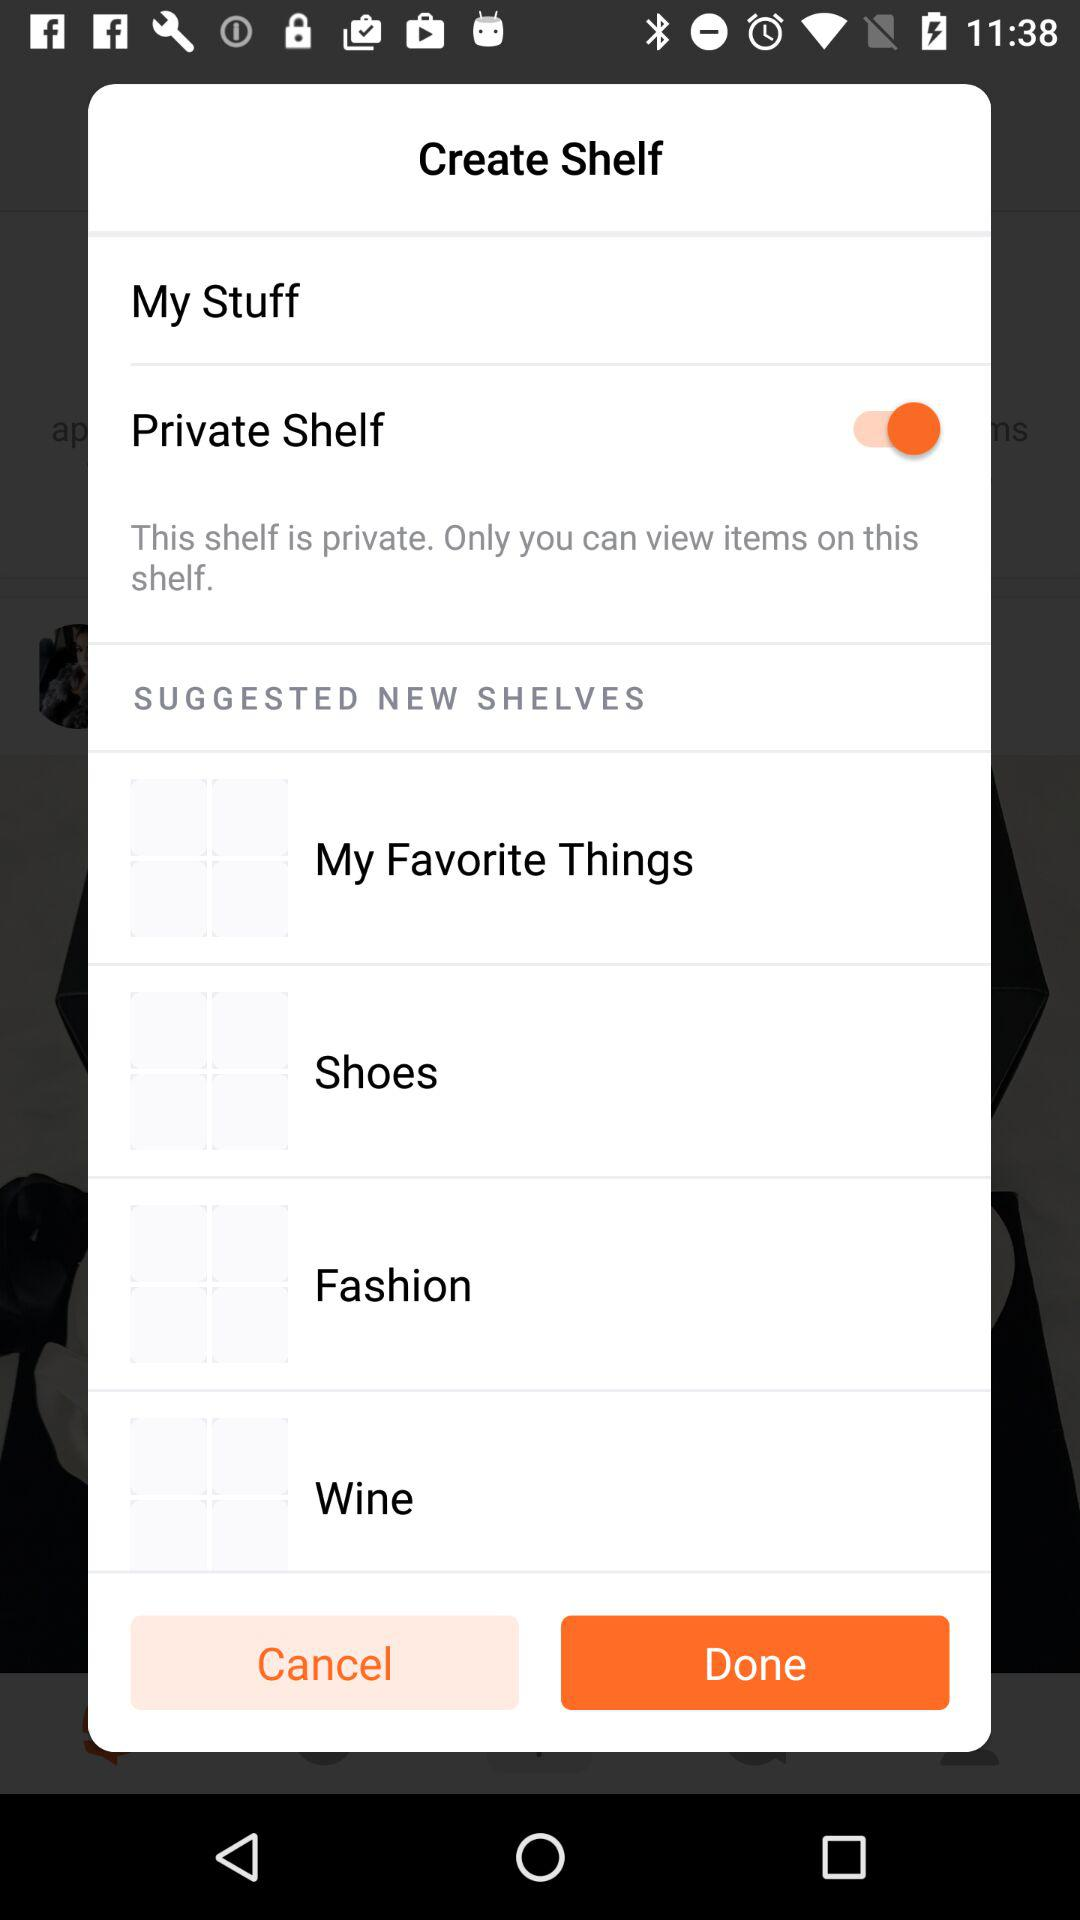How many suggested shelves are there?
Answer the question using a single word or phrase. 4 